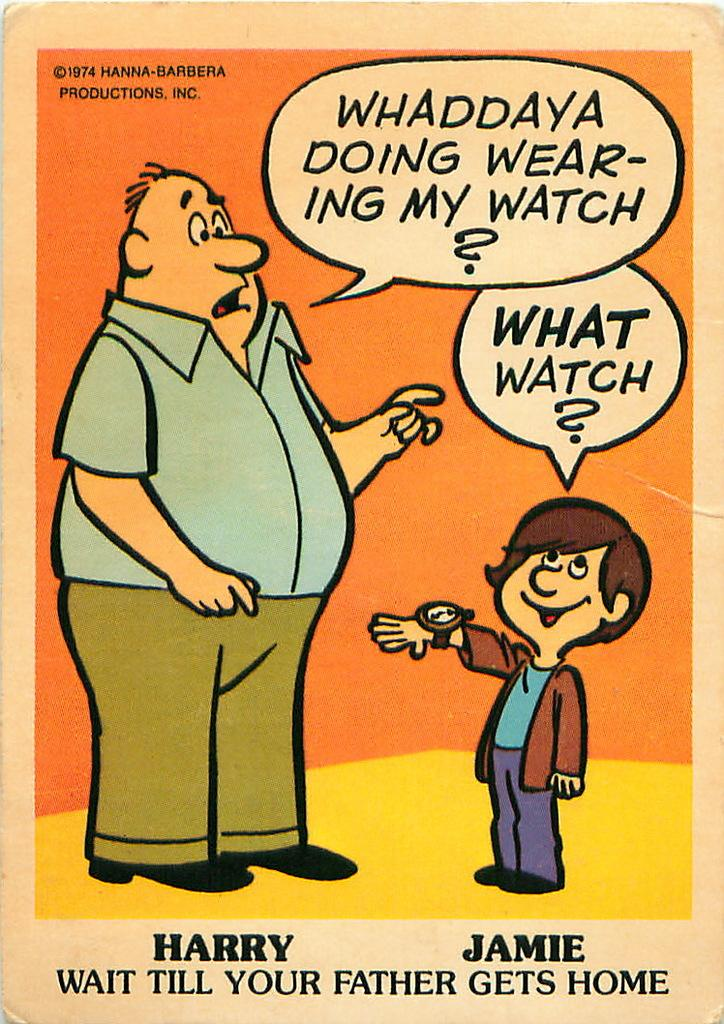What is the main subject of the image? The main subject of the image is a book cover. What type of images are on the book cover? A: There are cartoon images of two persons on the book cover. Are there any words on the book cover? Yes, there is text on the book cover. What type of calendar is visible on the book cover? There is no calendar present on the book cover; it features cartoon images of two persons and text. 